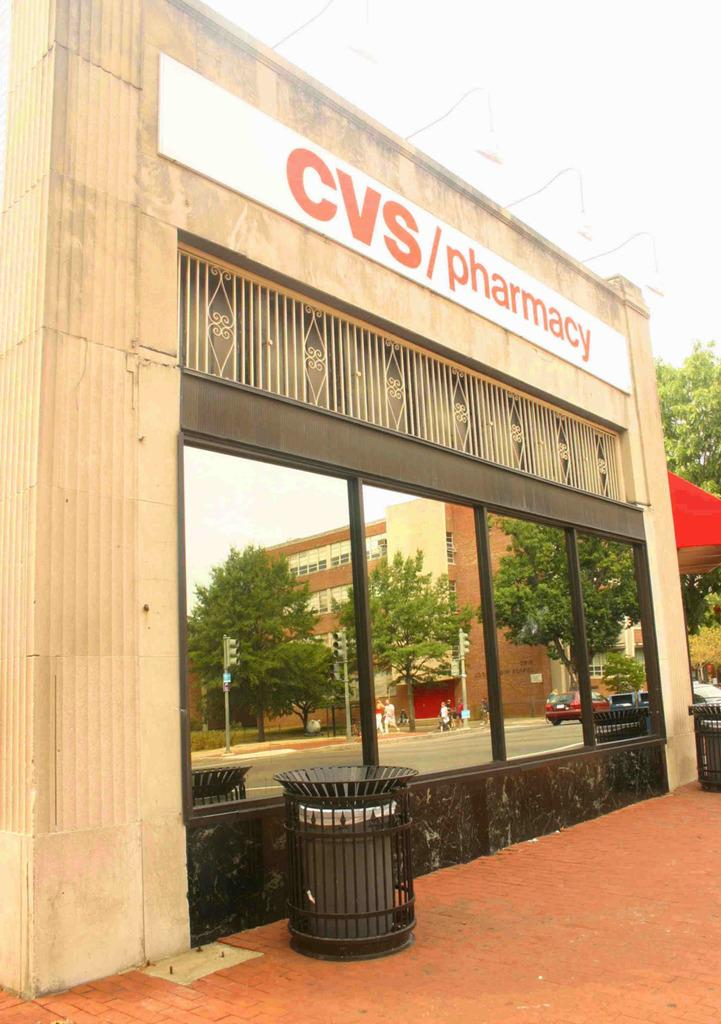Provide a one-sentence caption for the provided image. The front of a CVS with very clean windows. 